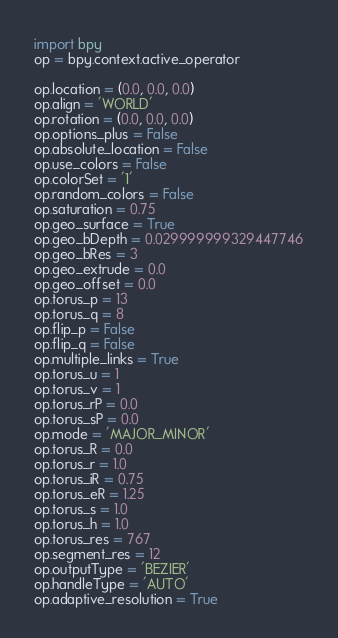Convert code to text. <code><loc_0><loc_0><loc_500><loc_500><_Python_>import bpy
op = bpy.context.active_operator

op.location = (0.0, 0.0, 0.0)
op.align = 'WORLD'
op.rotation = (0.0, 0.0, 0.0)
op.options_plus = False
op.absolute_location = False
op.use_colors = False
op.colorSet = '1'
op.random_colors = False
op.saturation = 0.75
op.geo_surface = True
op.geo_bDepth = 0.029999999329447746
op.geo_bRes = 3
op.geo_extrude = 0.0
op.geo_offset = 0.0
op.torus_p = 13
op.torus_q = 8
op.flip_p = False
op.flip_q = False
op.multiple_links = True
op.torus_u = 1
op.torus_v = 1
op.torus_rP = 0.0
op.torus_sP = 0.0
op.mode = 'MAJOR_MINOR'
op.torus_R = 0.0
op.torus_r = 1.0
op.torus_iR = 0.75
op.torus_eR = 1.25
op.torus_s = 1.0
op.torus_h = 1.0
op.torus_res = 767
op.segment_res = 12
op.outputType = 'BEZIER'
op.handleType = 'AUTO'
op.adaptive_resolution = True
</code> 